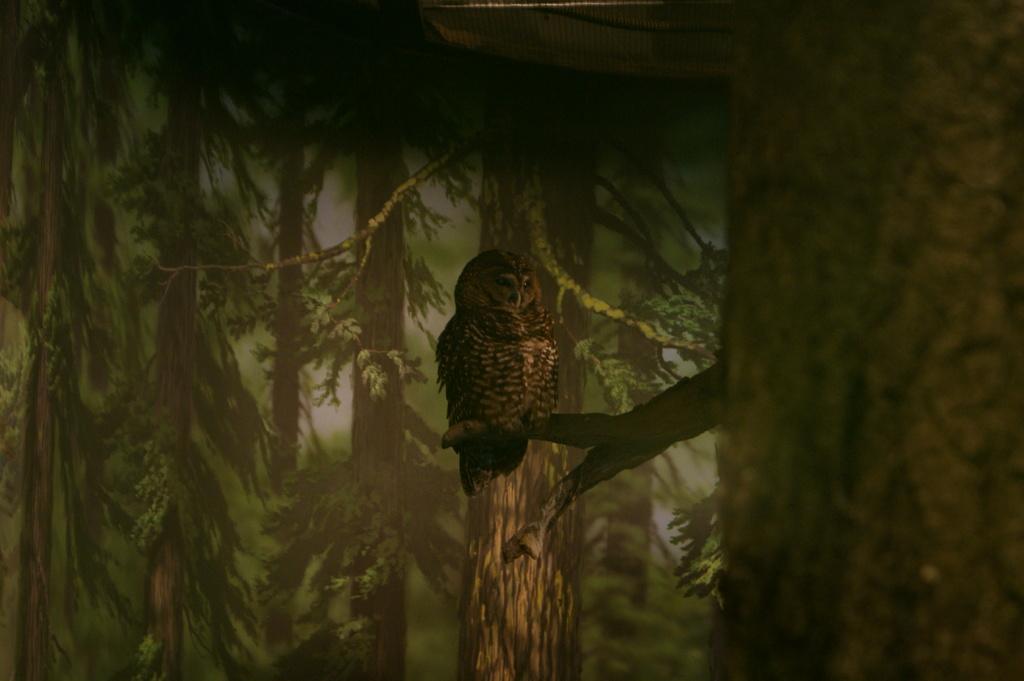Can you describe this image briefly? In this picture we can see an owl is standing on a branch of a tree, in the background there are some trees. 